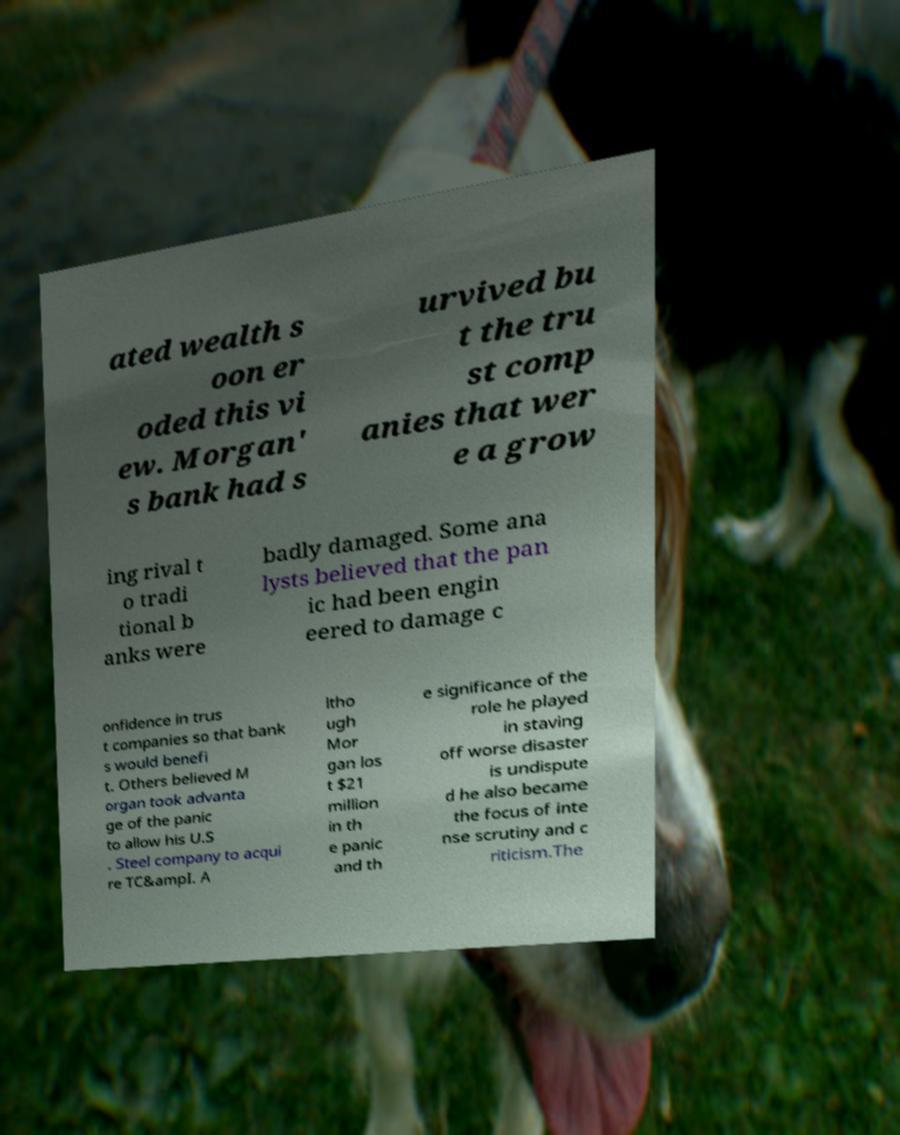Can you accurately transcribe the text from the provided image for me? ated wealth s oon er oded this vi ew. Morgan' s bank had s urvived bu t the tru st comp anies that wer e a grow ing rival t o tradi tional b anks were badly damaged. Some ana lysts believed that the pan ic had been engin eered to damage c onfidence in trus t companies so that bank s would benefi t. Others believed M organ took advanta ge of the panic to allow his U.S . Steel company to acqui re TC&ampI. A ltho ugh Mor gan los t $21 million in th e panic and th e significance of the role he played in staving off worse disaster is undispute d he also became the focus of inte nse scrutiny and c riticism.The 